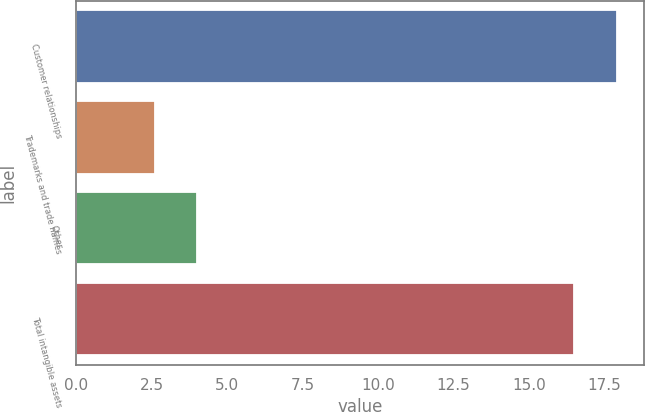Convert chart. <chart><loc_0><loc_0><loc_500><loc_500><bar_chart><fcel>Customer relationships<fcel>Trademarks and trade names<fcel>Other<fcel>Total intangible assets<nl><fcel>17.91<fcel>2.6<fcel>4.01<fcel>16.5<nl></chart> 